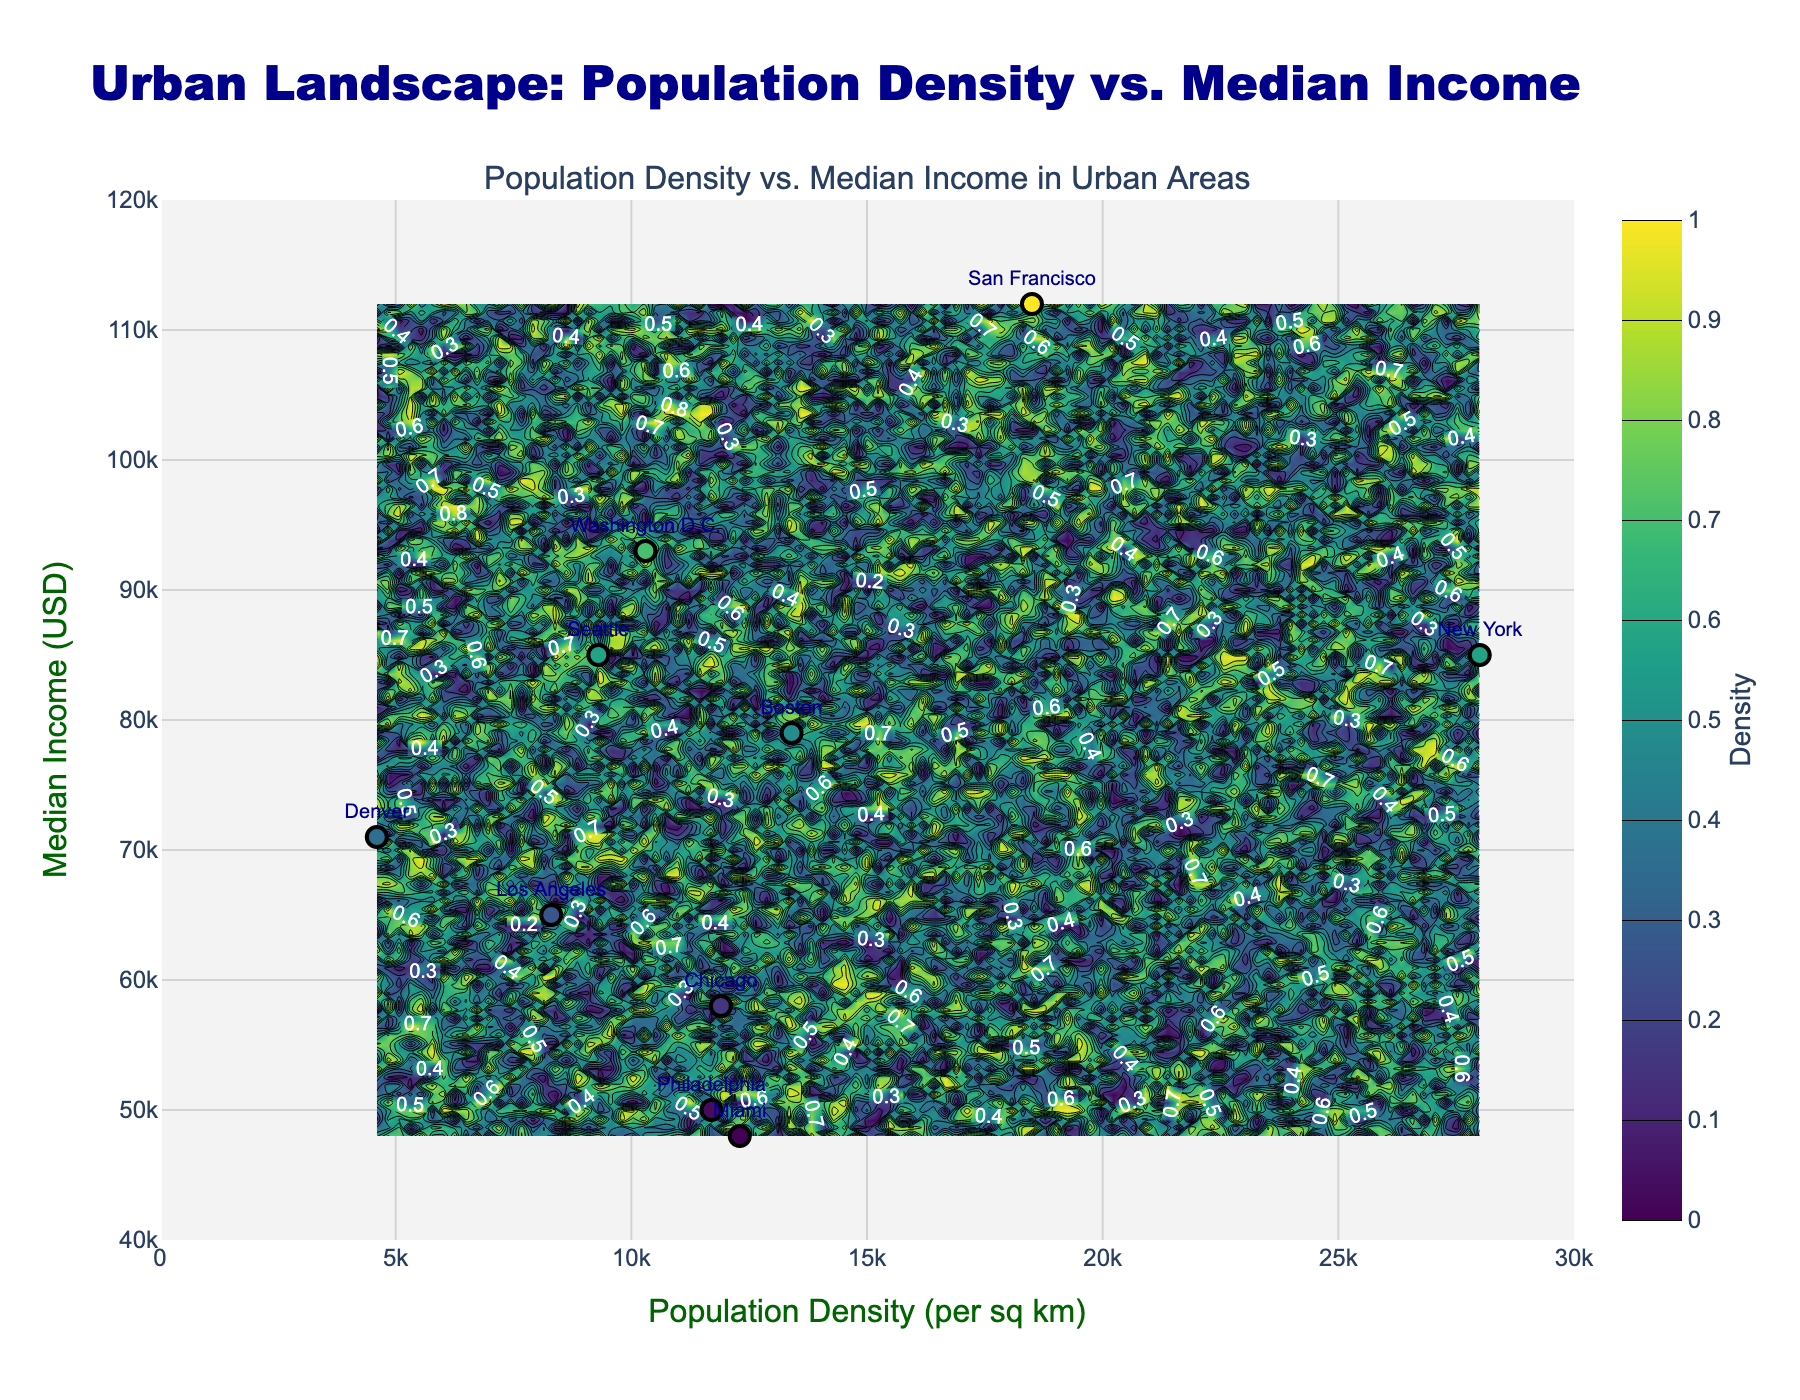What is the title of the plot? The title of the plot is written at the top of the figure with a larger, bold, and dark blue font.
Answer: Urban Landscape: Population Density vs. Median Income Which city has the highest median income? The city with the highest median income is labeled on the plot at the top of the vertical axis (Median Income). That city is San Francisco with a median income of $112,000.
Answer: San Francisco What is the color scale used for the contour plot? The contour plot uses a color scale that transitions through shades of green to blue, representing density levels from low to high. This common color scale is known as 'Viridis'.
Answer: Viridis Which city has the lowest population density and what is its corresponding median income? The data points that represent cities are marked, and their names are shown. Denver has the lowest population density marked nearest to zero on the horizontal axis, with a corresponding median income of $71,000.
Answer: Denver, $71,000 How are the values of population density and median income distributed amongst the cities? The contour plot indicates broader regions of varying density levels and the scatter plot labels each city point. The cities are spread across different regions of population density, but most cities have median income values between $50,000 and $90,000.
Answer: Distributed across various densities, mostly $50,000-$90,000 Which city has the closest median income to the overall average of all listed cities? To find this, we calculate the average median income of all cities (sum of all median incomes divided by the number of cities). Comparing the values, Seattle and New York, both at $85,000, are closest to this average. Calculation: (85000 + 112000 + 65000 + 58000 + 93000 + 79000 + 48000 + 85000 + 50000 + 71000)/10 = $78000. New York and Seattle's incomes are closest to this average.
Answer: Seattle and New York Is there a visible trend between population density and median income in this plot? The scatter plot does not show a clear linear correlation through a single trend line, and the contour plot’s color intensity (density) indicates that median incomes can be high or low across different population densities without a consistent trend.
Answer: No clear trend Which cities are positioned inside high-density contours on the plot? High-density regions on the contour plot are typically in darker shades. Looking at these regions, New York and San Francisco lie within the higher density areas.
Answer: New York and San Francisco Are there any cities with the same median income? If so, identify them. By examining the labels, New York and Seattle are both marked with a median income of $85,000, meaning they share the same median income value.
Answer: New York and Seattle Compare the median income of Philadelphia and Miami; which city has a higher value? Based on the labeled scatter plot, Philadelphia has a median income of $50,000 whereas Miami has a median income of $48,000. Therefore, Philadelphia has a slightly higher median income.
Answer: Philadelphia 